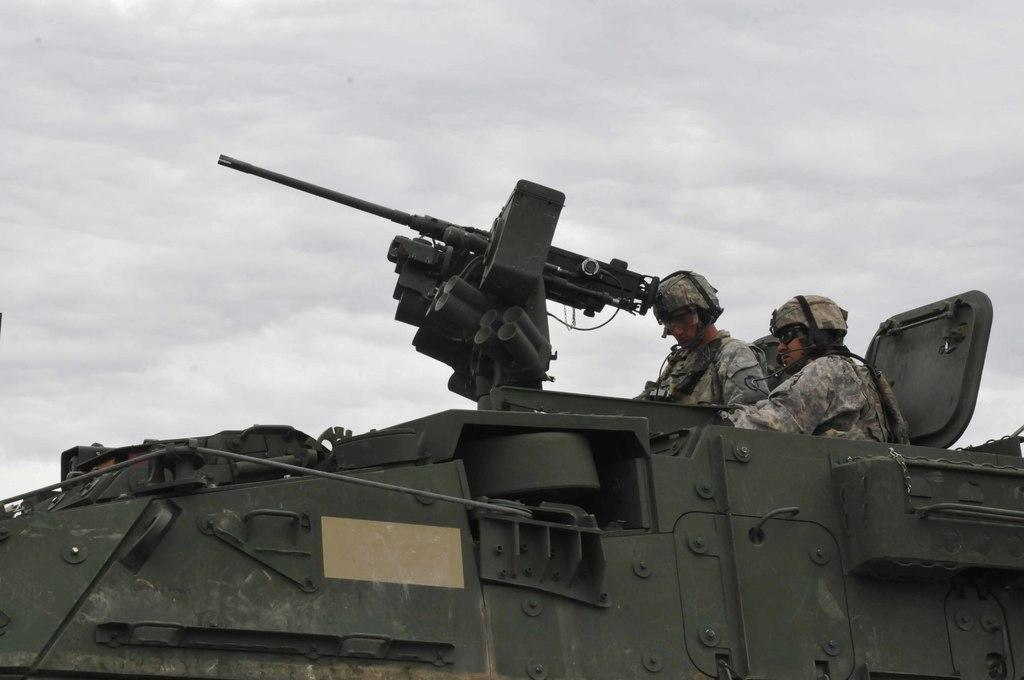What is the main subject of the image? The main subject of the image is a war tanker. Who or what is inside the tanker? Inside the tanker, there are two men. What protective gear are the men wearing? The men are wearing helmets and goggles. What can be seen in the background of the image? There is sky visible in the background of the image. What type of vacation destination is depicted in the image? There is no vacation destination present in the image; it features a war tanker with two men wearing helmets and goggles. Can you tell me how many lamps are visible in the image? There are no lamps visible in the image. 